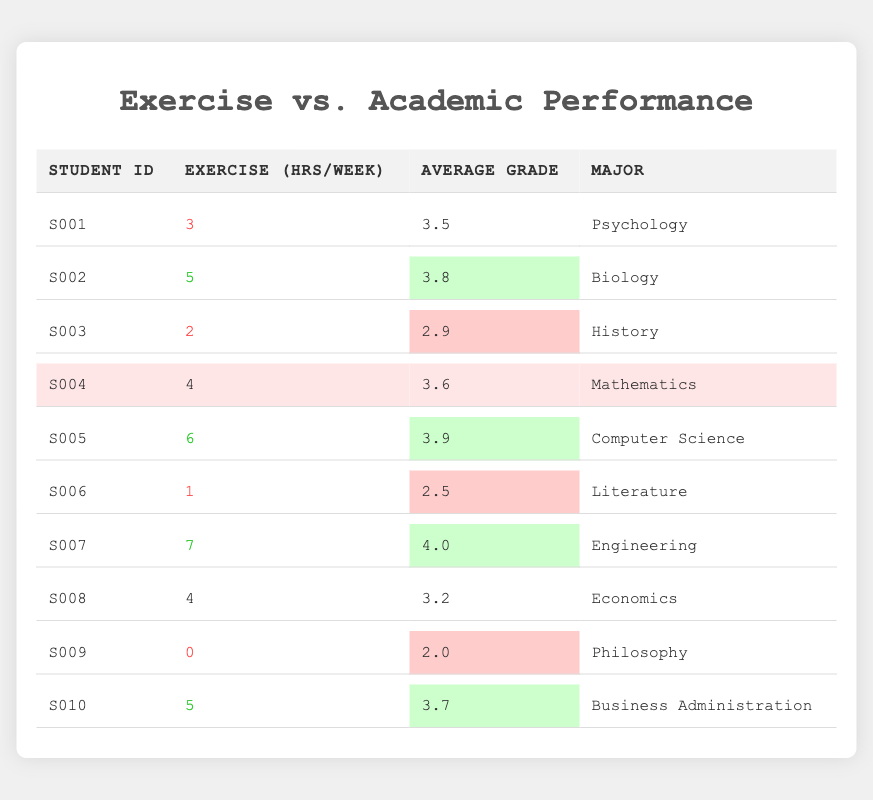What is the maximum number of exercise hours per week recorded in the table? Looking through the "Exercise (hrs/week)" column, the maximum value is found by comparing all the values. The highest is 7 hours per week from student S007.
Answer: 7 Which student has the lowest average grade? By scanning the "Average Grade" column, the lowest value is 2.0, which corresponds to student S009.
Answer: S009 What is the average grade of students who exercise more than 4 hours per week? The students who exercise more than 4 hours are S005 (3.9), S007 (4.0), and S002 (3.8). Summing these grades gives 3.9 + 4.0 + 3.8 = 11.7. There are 3 students, so the average is 11.7 / 3 = 3.9.
Answer: 3.9 Is there a student who exercises less than 2 hours per week? Checking the "Exercise (hrs/week)" column, the lowest number is 0 hours by student S009, which confirms that there is indeed a student exercising less than 2 hours.
Answer: Yes How many students have an average grade of 3.5 or higher? The students with grades 3.5 or higher are S001 (3.5), S002 (3.8), S004 (3.6), S005 (3.9), S007 (4.0), S010 (3.7). Counting these gives 6 students.
Answer: 6 What is the total exercise hours per week summed for all students? Adding all exercise hours gives 3 + 5 + 2 + 4 + 6 + 1 + 7 + 4 + 0 + 5 = 37 hours.
Answer: 37 Are there any students who both exercise more than 5 hours and have an average grade higher than 3.5? Analyzing the data, S005 exercises 6 hours with a grade of 3.9 and S007 exercises 7 hours with a grade of 4.0. Both meet the criteria.
Answer: Yes What is the average exercise hours for students majoring in Psychology and Literature? The relevant students are S001 (3 hours) and S006 (1 hour). Their total exercise hours are 3 + 1 = 4. The average is 4 / 2 = 2.
Answer: 2 Which major has the highest average grade? The student grades are: Psychology (3.5), Biology (3.8), History (2.9), Mathematics (3.6), Computer Science (3.9), Literature (2.5), Engineering (4.0), Economics (3.2), Philosophy (2.0), Business Administration (3.7). The highest average grade is 4.0 from Engineering.
Answer: Engineering 